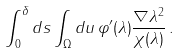Convert formula to latex. <formula><loc_0><loc_0><loc_500><loc_500>\int _ { 0 } ^ { \delta } d s \int _ { \Omega } d u \, \varphi ^ { \prime } ( \lambda ) \frac { \| \nabla \lambda \| ^ { 2 } } { \chi ( \lambda ) } \, .</formula> 